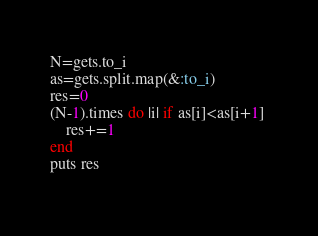<code> <loc_0><loc_0><loc_500><loc_500><_Ruby_>N=gets.to_i
as=gets.split.map(&:to_i)
res=0
(N-1).times do |i| if as[i]<as[i+1] 
    res+=1 
end
puts res
  
</code> 